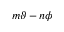Convert formula to latex. <formula><loc_0><loc_0><loc_500><loc_500>m \vartheta - n \phi</formula> 